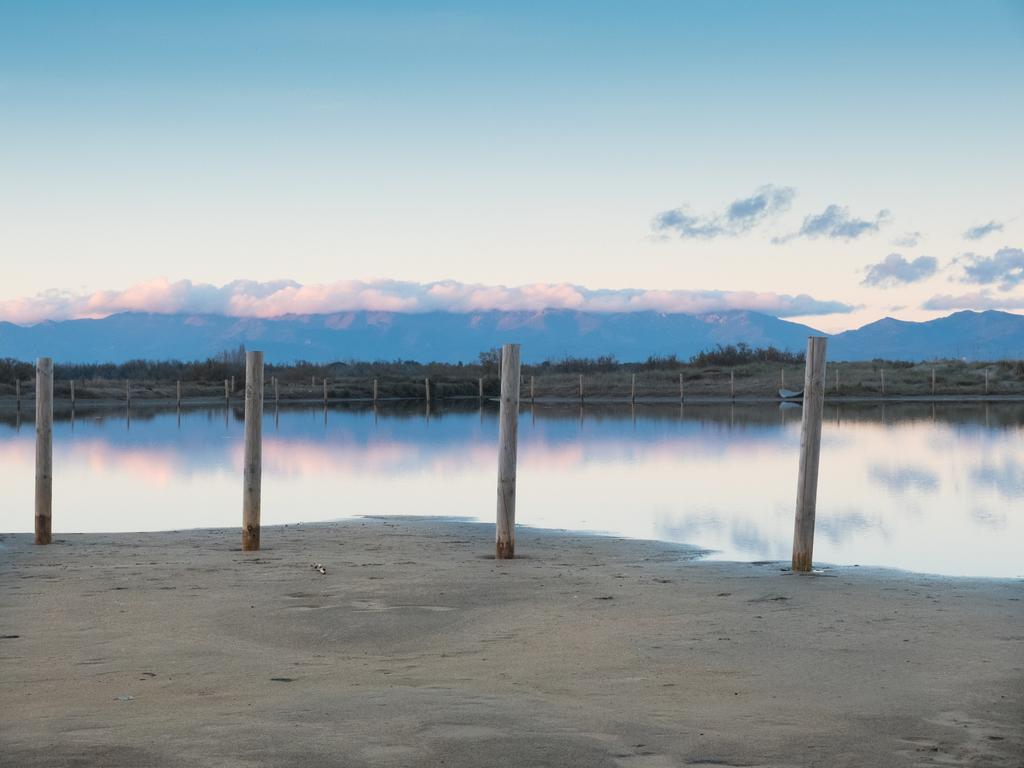Can you describe this image briefly? In this picture, we can see ground, poles, water, plants, mountains, and the sky with clouds. 